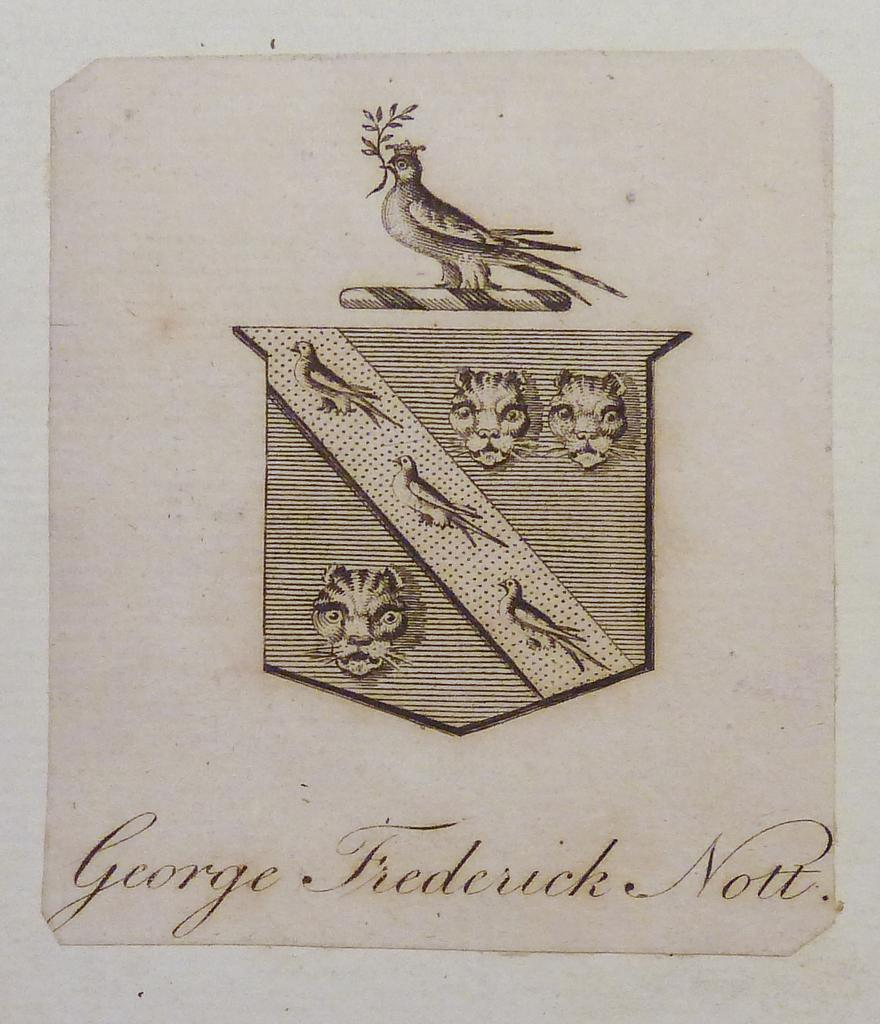What type of animals are depicted in the art of the image? There are a few birds in the art of the image. What other animal can be seen in the image? The face of a lion is present in the image. Is there any text included in the image? Yes, there is text at the bottom of the image. What type of chicken is shown in the frame in the image? There is no chicken or frame present in the image. 